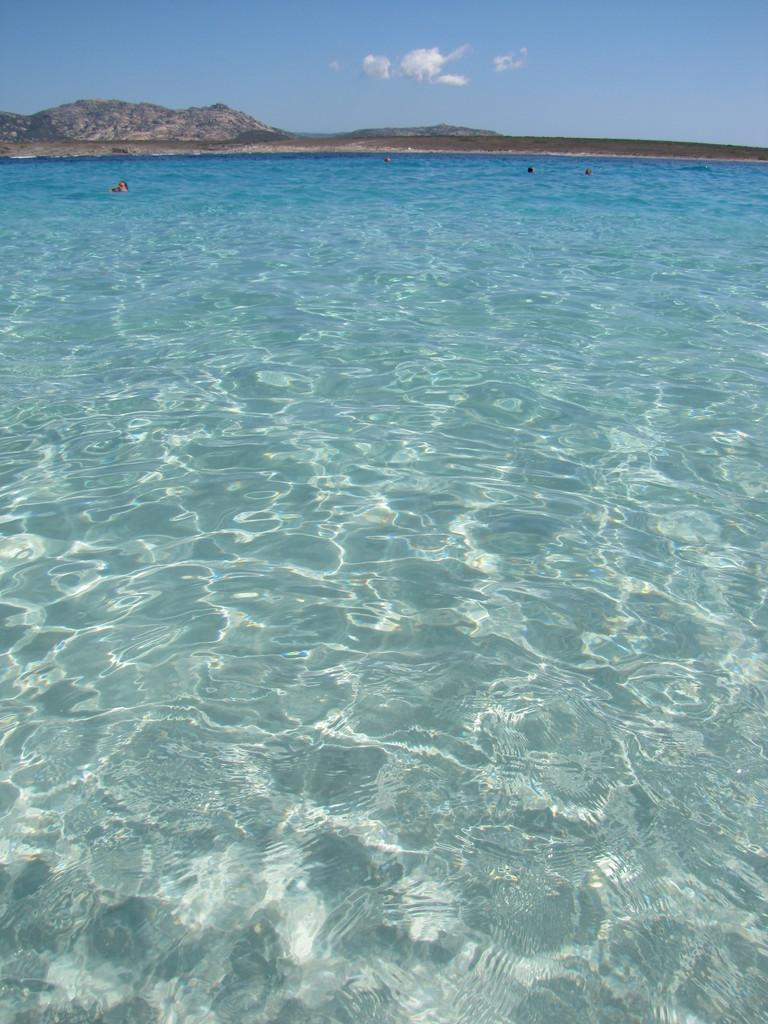What is the main subject of the image? The main subject of the image is water. What are the people in the image doing? The people in the image are swimming in the water. How would you describe the sky in the image? The sky is blue and cloudy in the image. Are there any slaves visible in the image? There is no mention of slaves in the image, and therefore no such individuals can be observed. What type of umbrella is being used by the swimmers in the image? There are no umbrellas present in the image; it features people swimming in water. 